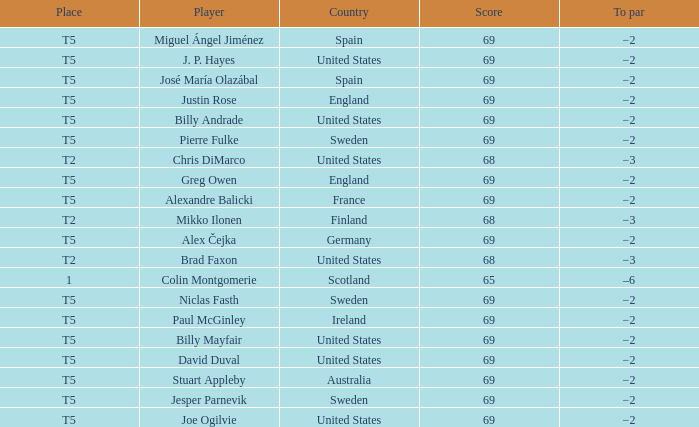Help me parse the entirety of this table. {'header': ['Place', 'Player', 'Country', 'Score', 'To par'], 'rows': [['T5', 'Miguel Ángel Jiménez', 'Spain', '69', '−2'], ['T5', 'J. P. Hayes', 'United States', '69', '−2'], ['T5', 'José María Olazábal', 'Spain', '69', '−2'], ['T5', 'Justin Rose', 'England', '69', '−2'], ['T5', 'Billy Andrade', 'United States', '69', '−2'], ['T5', 'Pierre Fulke', 'Sweden', '69', '−2'], ['T2', 'Chris DiMarco', 'United States', '68', '−3'], ['T5', 'Greg Owen', 'England', '69', '−2'], ['T5', 'Alexandre Balicki', 'France', '69', '−2'], ['T2', 'Mikko Ilonen', 'Finland', '68', '−3'], ['T5', 'Alex Čejka', 'Germany', '69', '−2'], ['T2', 'Brad Faxon', 'United States', '68', '−3'], ['1', 'Colin Montgomerie', 'Scotland', '65', '–6'], ['T5', 'Niclas Fasth', 'Sweden', '69', '−2'], ['T5', 'Paul McGinley', 'Ireland', '69', '−2'], ['T5', 'Billy Mayfair', 'United States', '69', '−2'], ['T5', 'David Duval', 'United States', '69', '−2'], ['T5', 'Stuart Appleby', 'Australia', '69', '−2'], ['T5', 'Jesper Parnevik', 'Sweden', '69', '−2'], ['T5', 'Joe Ogilvie', 'United States', '69', '−2']]} What place did Paul McGinley finish in? T5. 